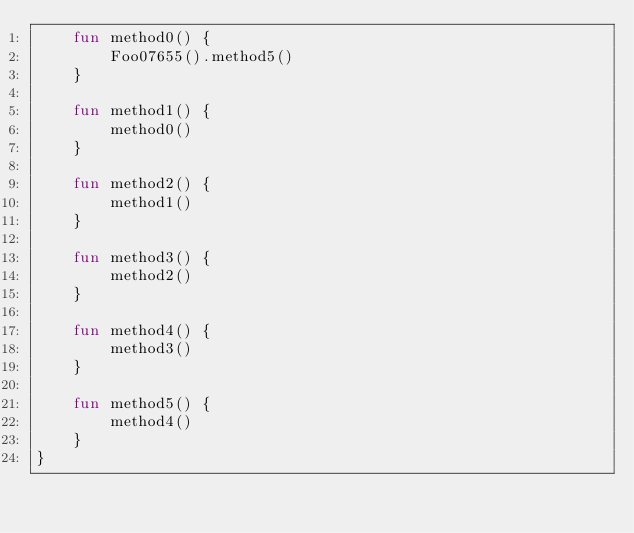<code> <loc_0><loc_0><loc_500><loc_500><_Kotlin_>    fun method0() {
        Foo07655().method5()
    }

    fun method1() {
        method0()
    }

    fun method2() {
        method1()
    }

    fun method3() {
        method2()
    }

    fun method4() {
        method3()
    }

    fun method5() {
        method4()
    }
}
</code> 